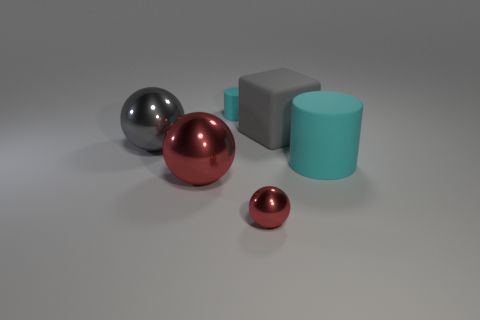Is there a sense of balance in the composition of this image? The composition does convey a sense of visual balance. The objects are evenly spaced and their placement seems deliberate. The variety in size and color among the spheres and cubes, along with their arrangement, creates a harmonious and aesthetically pleasing scene.  Does the image give any insight into the objects' material properties? Indeed. The differing surfaces suggest diverse material properties. The reflective spheres seem to be made of a polished metal, whereas the matte objects could be composed of a more diffusive material like plastic or painted metal, which does not reflect light to the same degree. This contributes to the overall texture diversity in the image. 